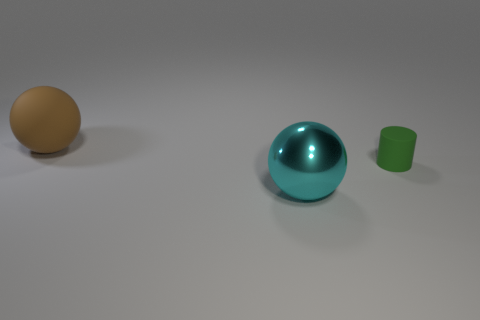Add 3 tiny green cylinders. How many objects exist? 6 Subtract all balls. How many objects are left? 1 Subtract all large red objects. Subtract all big cyan balls. How many objects are left? 2 Add 1 large brown objects. How many large brown objects are left? 2 Add 1 large cyan spheres. How many large cyan spheres exist? 2 Subtract 0 gray cylinders. How many objects are left? 3 